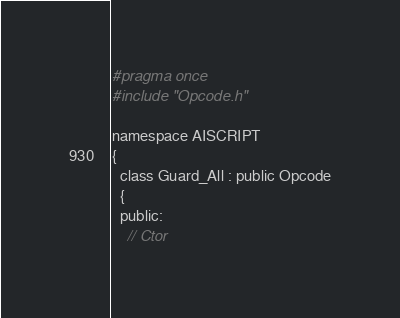Convert code to text. <code><loc_0><loc_0><loc_500><loc_500><_C_>#pragma once
#include "Opcode.h"

namespace AISCRIPT
{
  class Guard_All : public Opcode
  {
  public:
    // Ctor</code> 